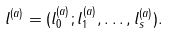Convert formula to latex. <formula><loc_0><loc_0><loc_500><loc_500>l ^ { ( a ) } = ( l ^ { ( a ) } _ { 0 } ; l ^ { ( a ) } _ { 1 } , \dots , l ^ { ( a ) } _ { s } ) .</formula> 